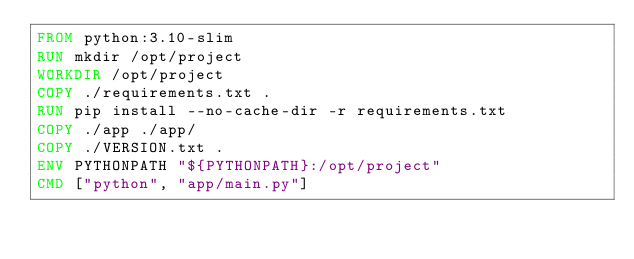<code> <loc_0><loc_0><loc_500><loc_500><_Dockerfile_>FROM python:3.10-slim
RUN mkdir /opt/project
WORKDIR /opt/project
COPY ./requirements.txt .
RUN pip install --no-cache-dir -r requirements.txt
COPY ./app ./app/
COPY ./VERSION.txt .
ENV PYTHONPATH "${PYTHONPATH}:/opt/project"
CMD ["python", "app/main.py"]
</code> 